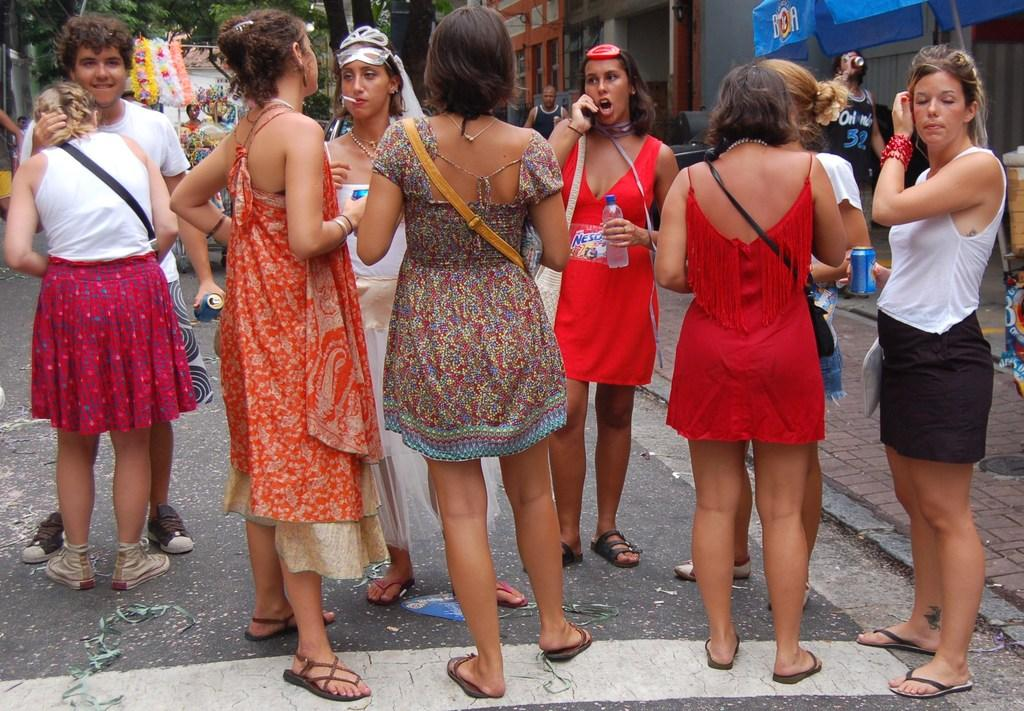What is the main subject of the image? The main subject of the image is a group of women. Where are the women located in the image? The women are standing in the middle of the image. What can be seen in the background of the image? There are trees and buildings in the background of the image. What type of fiction is being discussed at the meeting in the image? There is no meeting or discussion of fiction present in the image; it features a group of women standing in the middle of the image. 